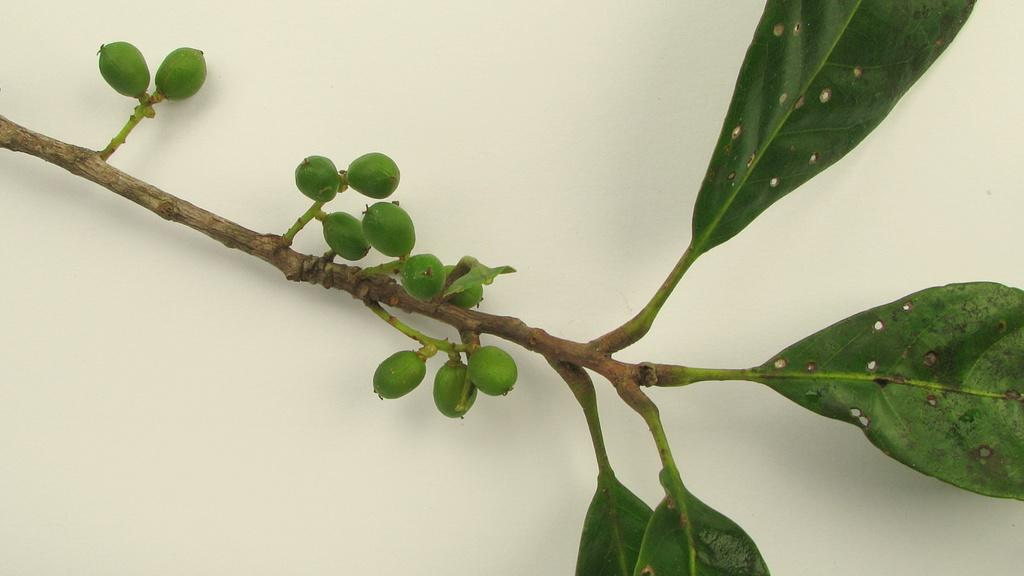What type of living organism is present in the image? There is a plant in the image. What color is the plant? The plant is green in color. What can be seen in the background of the image? There is a wall in the background of the image. What color is the wall? The wall is cream in color. What type of insurance policy is being discussed in the image? There is no mention of insurance or any discussion in the image; it features a plant and a cream-colored wall in the background. 